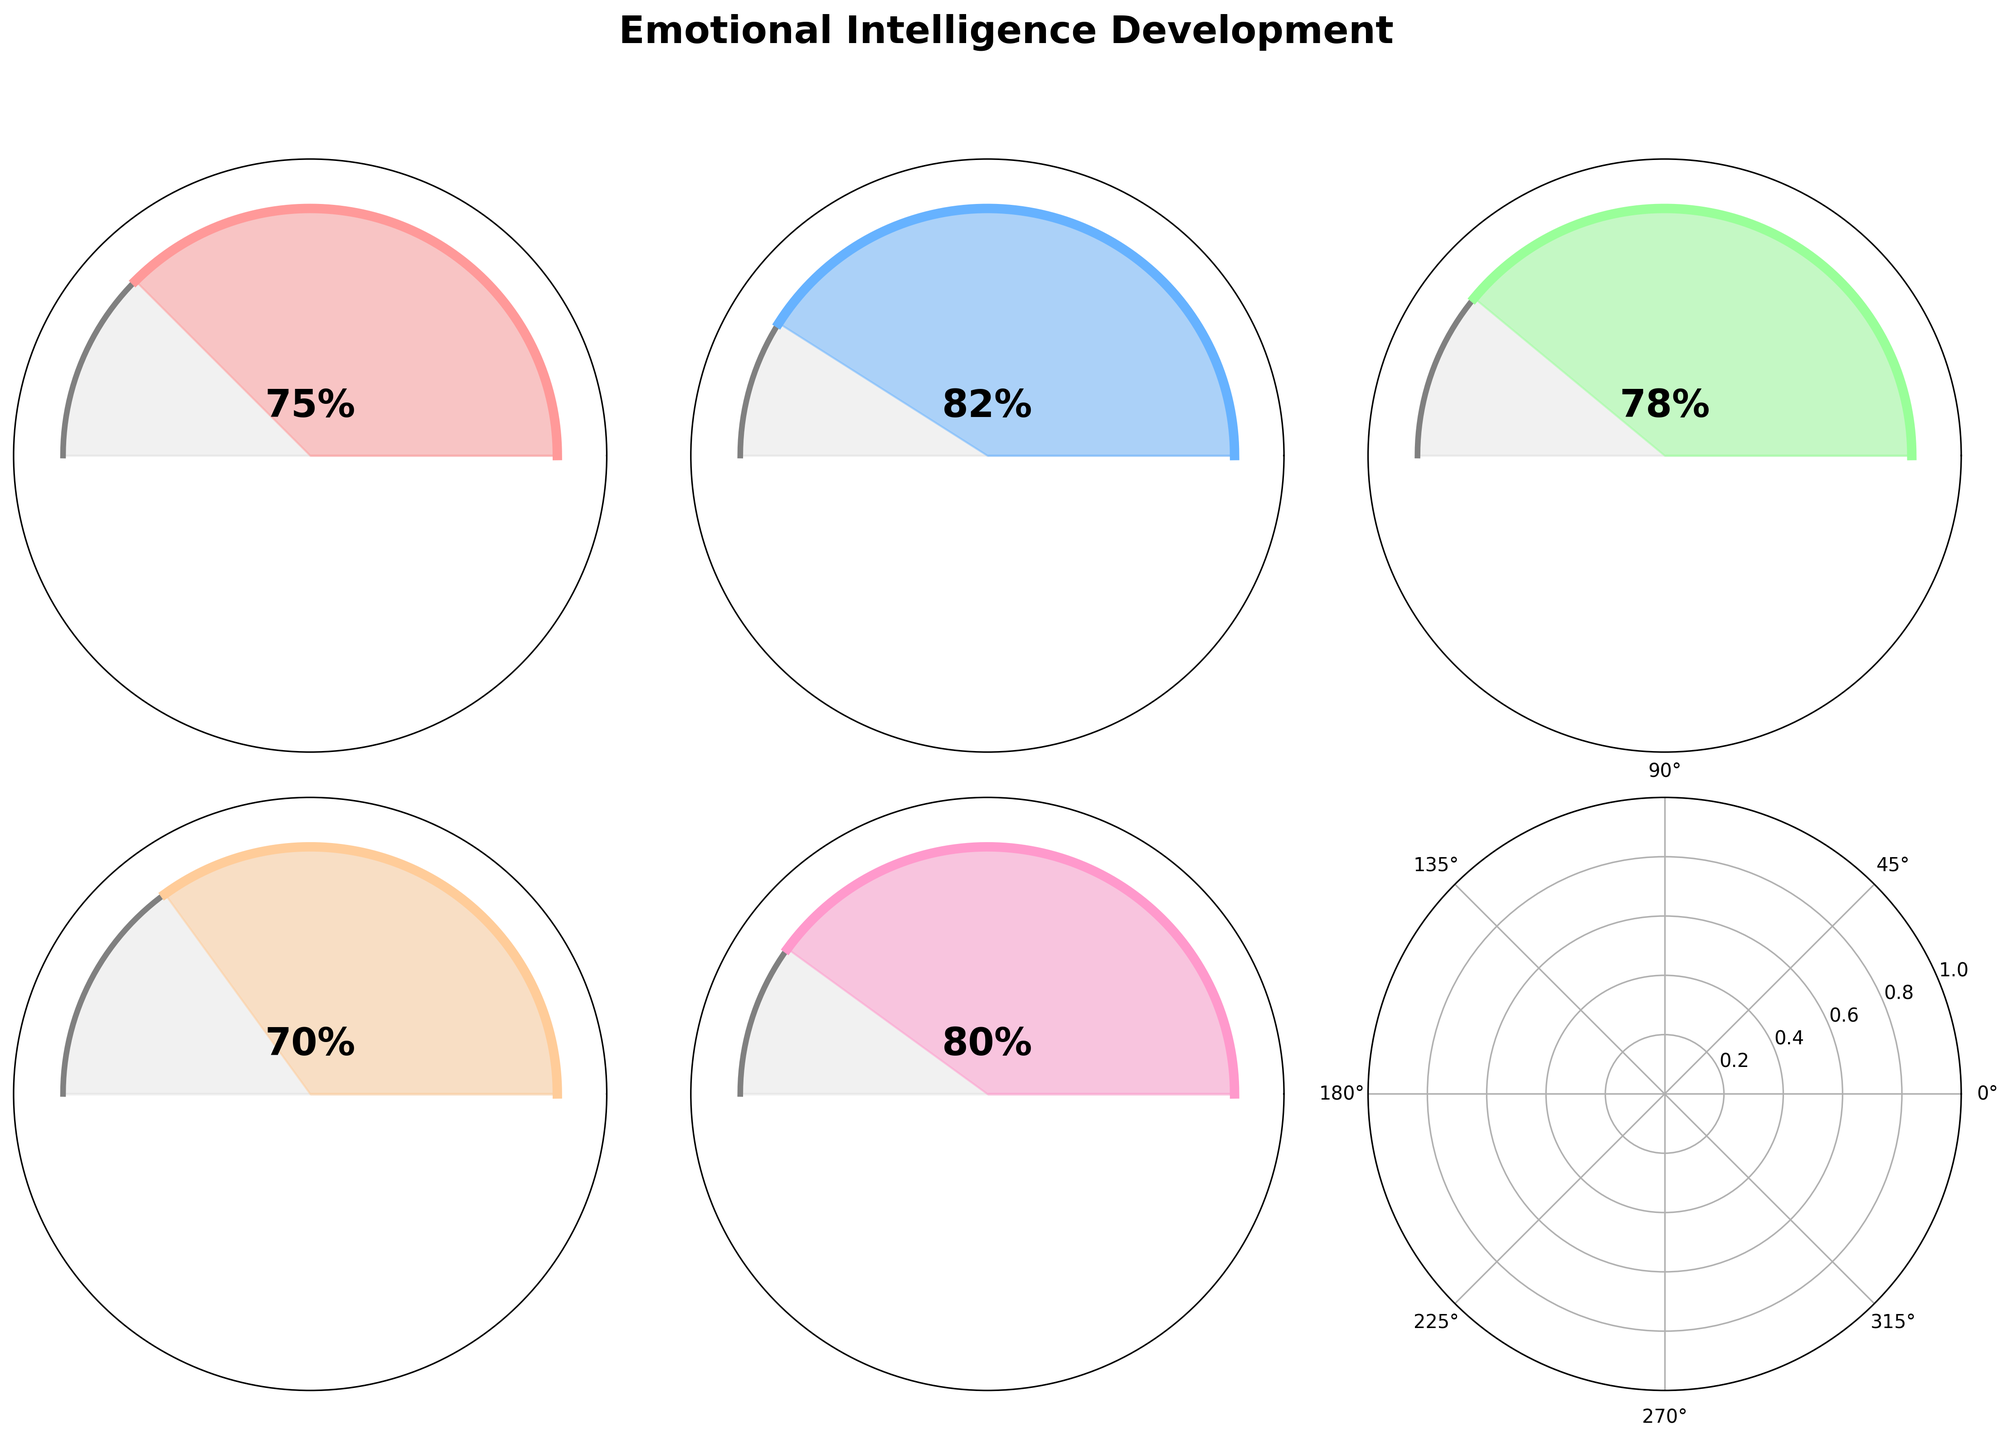What is the title of the figure? The title of the figure is located at the top and mentions the main theme. It reads "Emotional Intelligence Development".
Answer: Emotional Intelligence Development What is the score for Self-Awareness? The gauge for Self-Awareness has a value labeled at the center. The score is 75%.
Answer: 75% How many different aspects of emotional intelligence are displayed in the figure? The figure displays gauges for different aspects of emotional intelligence. Counting these, we see five aspects: Self-Awareness, Empathy, Social Skills, Emotional Regulation, and Motivation.
Answer: 5 Which aspect has the highest score? By comparing the values labeled on each gauge, we see that Empathy has the highest score at 82%.
Answer: Empathy Which aspects have scores greater than 75%? Reading the gauges, we see that Empathy (82%), Social Skills (78%), Motivation (80%), and Self-Awareness (75%) exceed a score of 75%.
Answer: Empathy, Social Skills, Motivation What is the average score across all aspects of emotional intelligence? To calculate the average, sum the scores (75 + 82 + 78 + 70 + 80 = 385) and divide by the number of aspects (5). The average score is 385/5 = 77%.
Answer: 77% Which aspect has the lowest score? By comparing the values on each gauge, Emotional Regulation has the lowest score at 70%.
Answer: Emotional Regulation What is the total score for all aspects of emotional intelligence combined? Adding all the scores together: 75 for Self-Awareness, 82 for Empathy, 78 for Social Skills, 70 for Emotional Regulation, and 80 for Motivation gives a total of 75+82+78+70+80 = 385.
Answer: 385 Is the score for Social Skills higher than the score for Self-Awareness? Checking the individual gauges, Social Skills has a score of 78%, which is higher than the 75% score for Self-Awareness.
Answer: Yes What is the difference in scores between the highest (Empathy) and lowest (Emotional Regulation) aspect? The highest score is 82% (Empathy) and the lowest is 70% (Emotional Regulation). Their difference is 82 - 70 = 12%.
Answer: 12% 